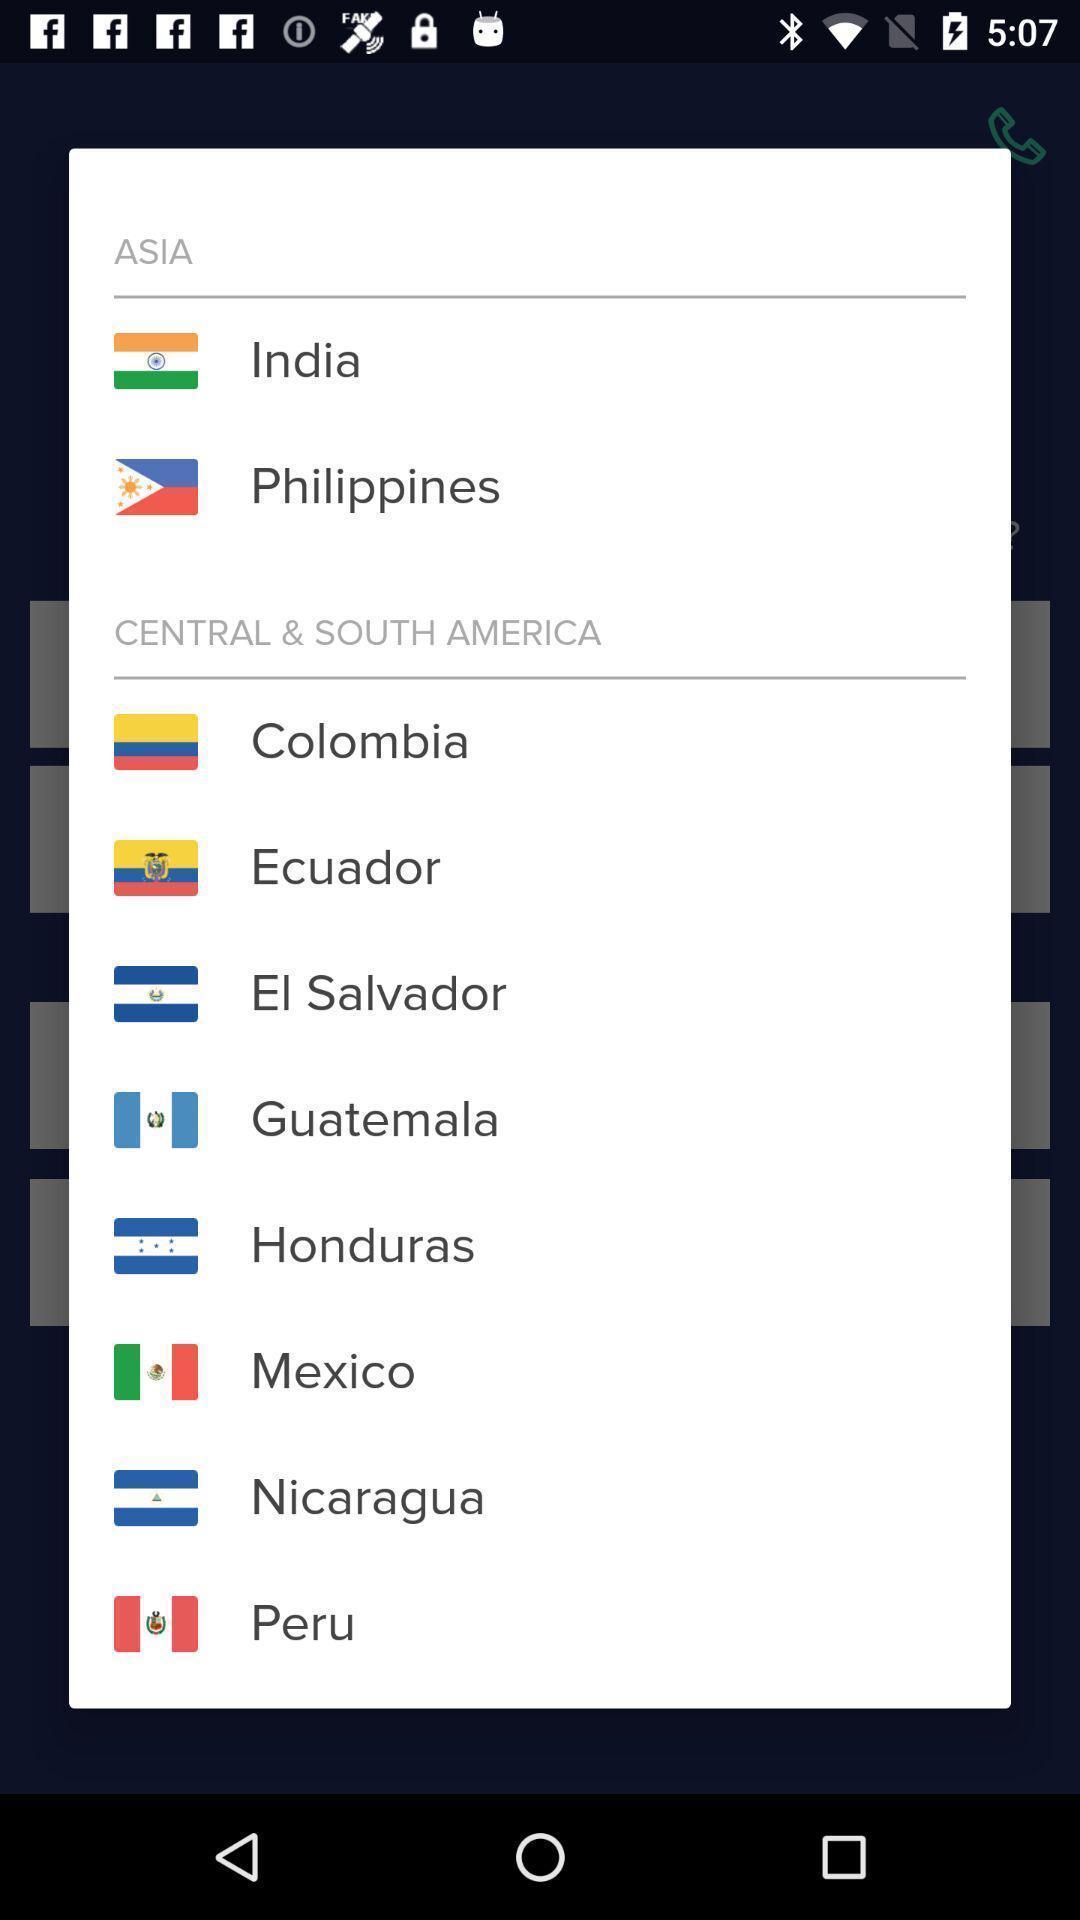Provide a detailed account of this screenshot. Pop-up showing different country names and the flags. 